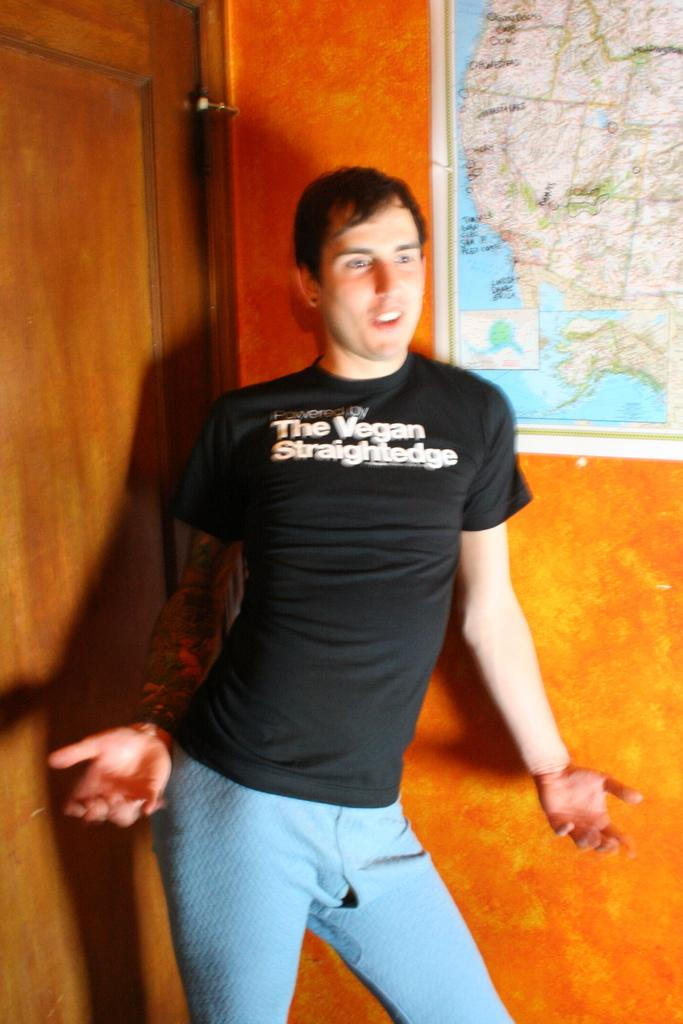<image>
Render a clear and concise summary of the photo. A man is posing in a very tight shirt that says The Vegan Straightedge 